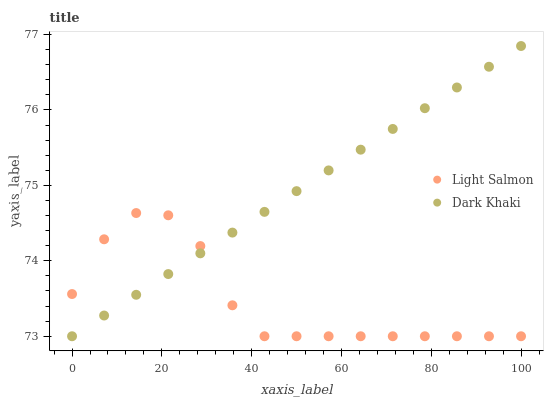Does Light Salmon have the minimum area under the curve?
Answer yes or no. Yes. Does Dark Khaki have the maximum area under the curve?
Answer yes or no. Yes. Does Light Salmon have the maximum area under the curve?
Answer yes or no. No. Is Dark Khaki the smoothest?
Answer yes or no. Yes. Is Light Salmon the roughest?
Answer yes or no. Yes. Is Light Salmon the smoothest?
Answer yes or no. No. Does Dark Khaki have the lowest value?
Answer yes or no. Yes. Does Dark Khaki have the highest value?
Answer yes or no. Yes. Does Light Salmon have the highest value?
Answer yes or no. No. Does Light Salmon intersect Dark Khaki?
Answer yes or no. Yes. Is Light Salmon less than Dark Khaki?
Answer yes or no. No. Is Light Salmon greater than Dark Khaki?
Answer yes or no. No. 